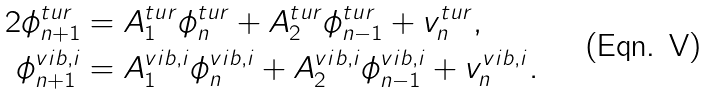<formula> <loc_0><loc_0><loc_500><loc_500>2 \phi ^ { t u r } _ { n + 1 } & = A _ { 1 } ^ { t u r } \phi ^ { t u r } _ { n } + A _ { 2 } ^ { t u r } \phi ^ { t u r } _ { n - 1 } + v ^ { t u r } _ { n } , \\ \phi ^ { v i b , i } _ { n + 1 } & = A _ { 1 } ^ { v i b , i } \phi ^ { v i b , i } _ { n } + A _ { 2 } ^ { v i b , i } \phi ^ { v i b , i } _ { n - 1 } + v ^ { v i b , i } _ { n } .</formula> 